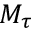<formula> <loc_0><loc_0><loc_500><loc_500>M _ { \tau }</formula> 